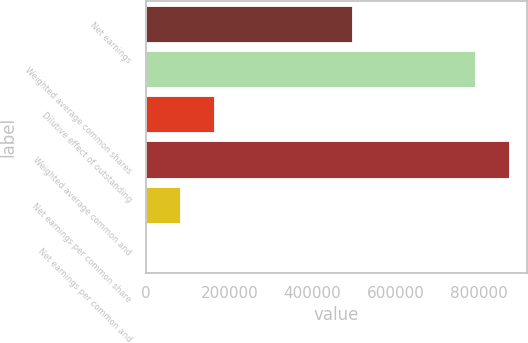Convert chart. <chart><loc_0><loc_0><loc_500><loc_500><bar_chart><fcel>Net earnings<fcel>Weighted average common shares<fcel>Dilutive effect of outstanding<fcel>Weighted average common and<fcel>Net earnings per common share<fcel>Net earnings per common and<nl><fcel>494370<fcel>789570<fcel>163084<fcel>871112<fcel>81542.2<fcel>0.61<nl></chart> 